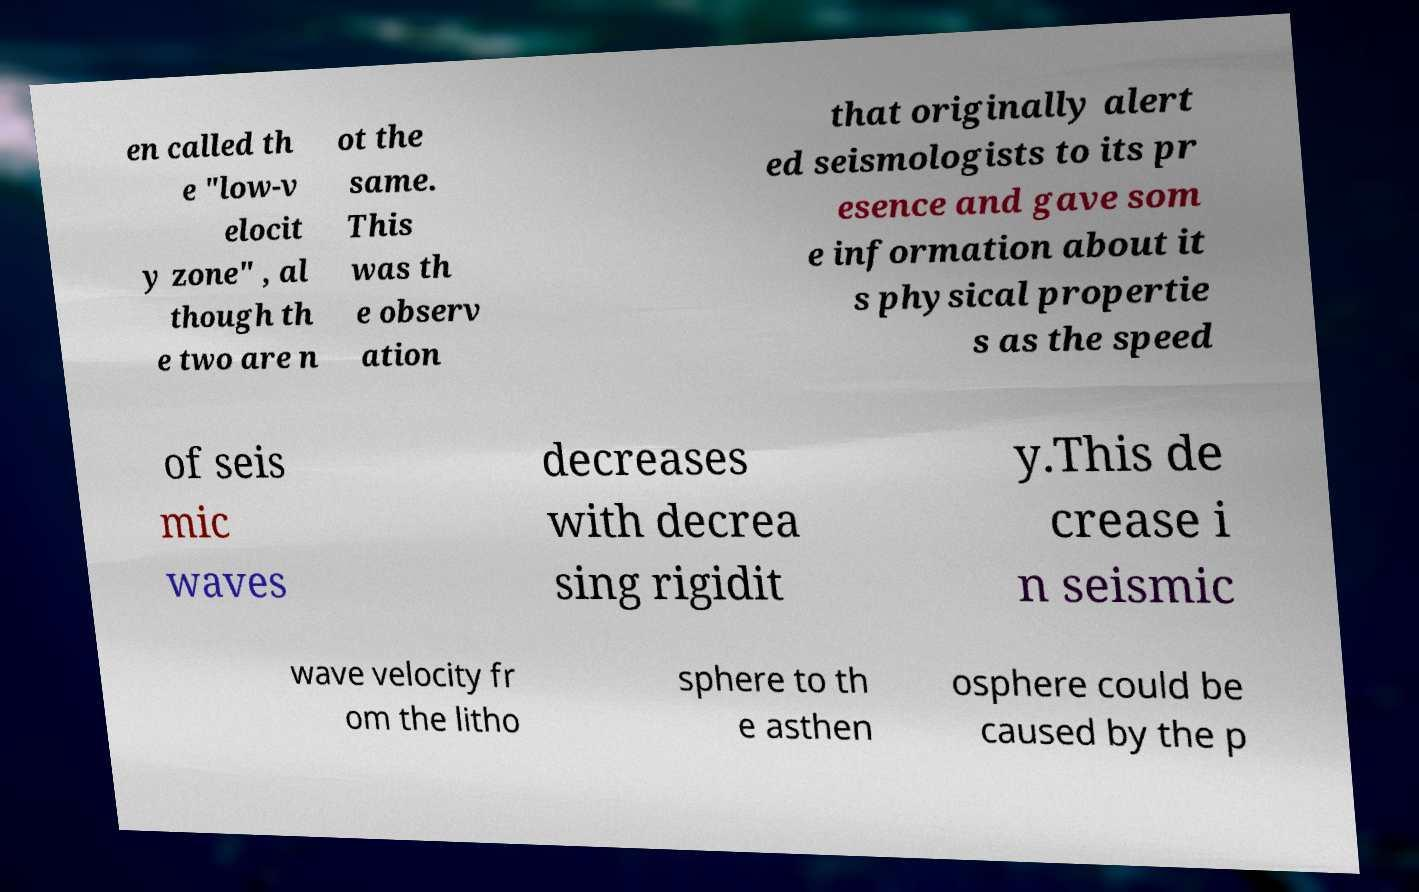Could you assist in decoding the text presented in this image and type it out clearly? en called th e "low-v elocit y zone" , al though th e two are n ot the same. This was th e observ ation that originally alert ed seismologists to its pr esence and gave som e information about it s physical propertie s as the speed of seis mic waves decreases with decrea sing rigidit y.This de crease i n seismic wave velocity fr om the litho sphere to th e asthen osphere could be caused by the p 